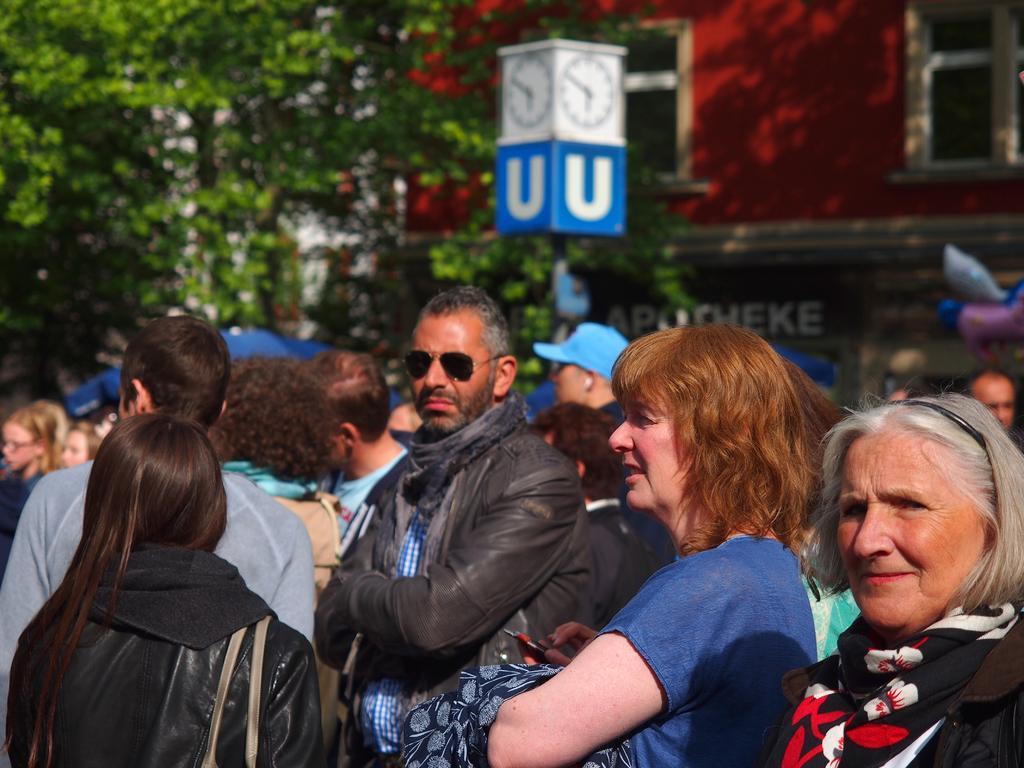Can you describe this image briefly? In this picture we can see a bag, scarf, jacket, goggles, cap, clocks, pole and a group of people standing and in the background we can see trees, building with windows. 